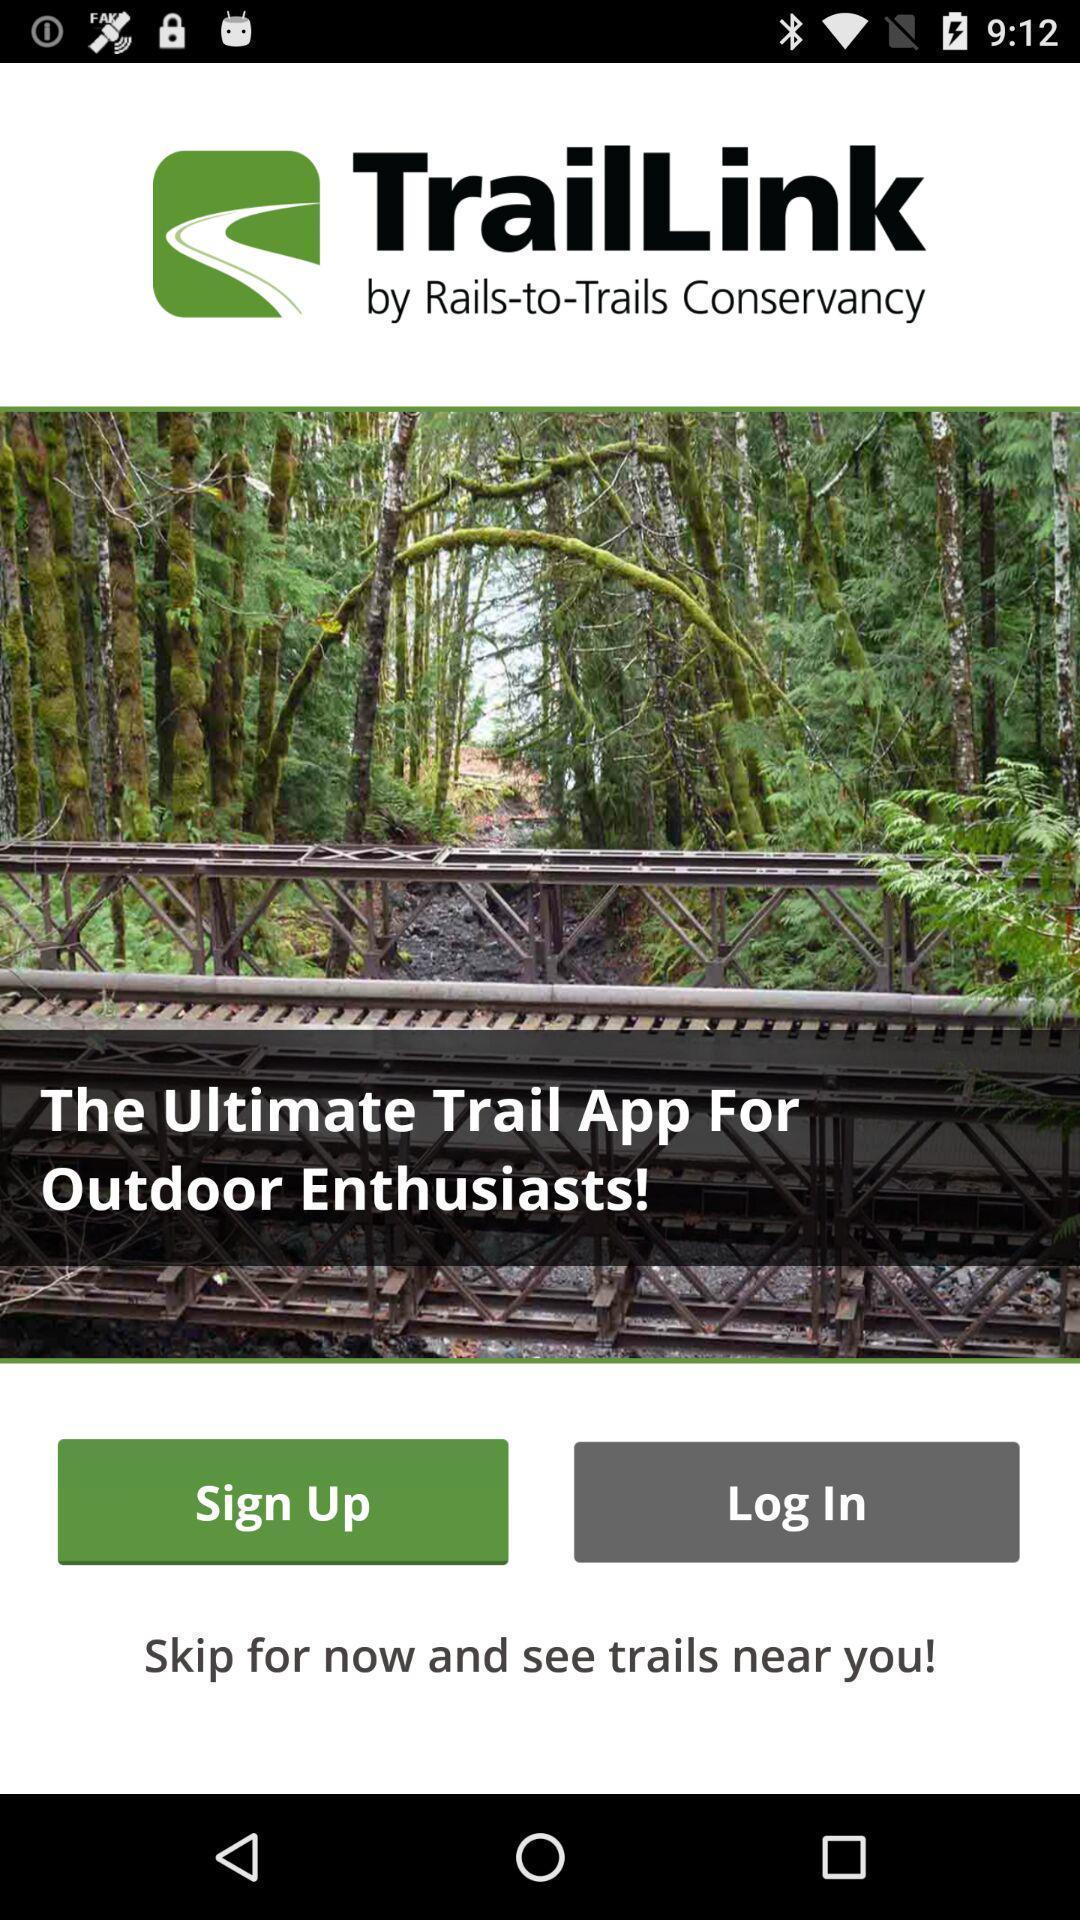Please provide a description for this image. Welcome page of a travel application. 